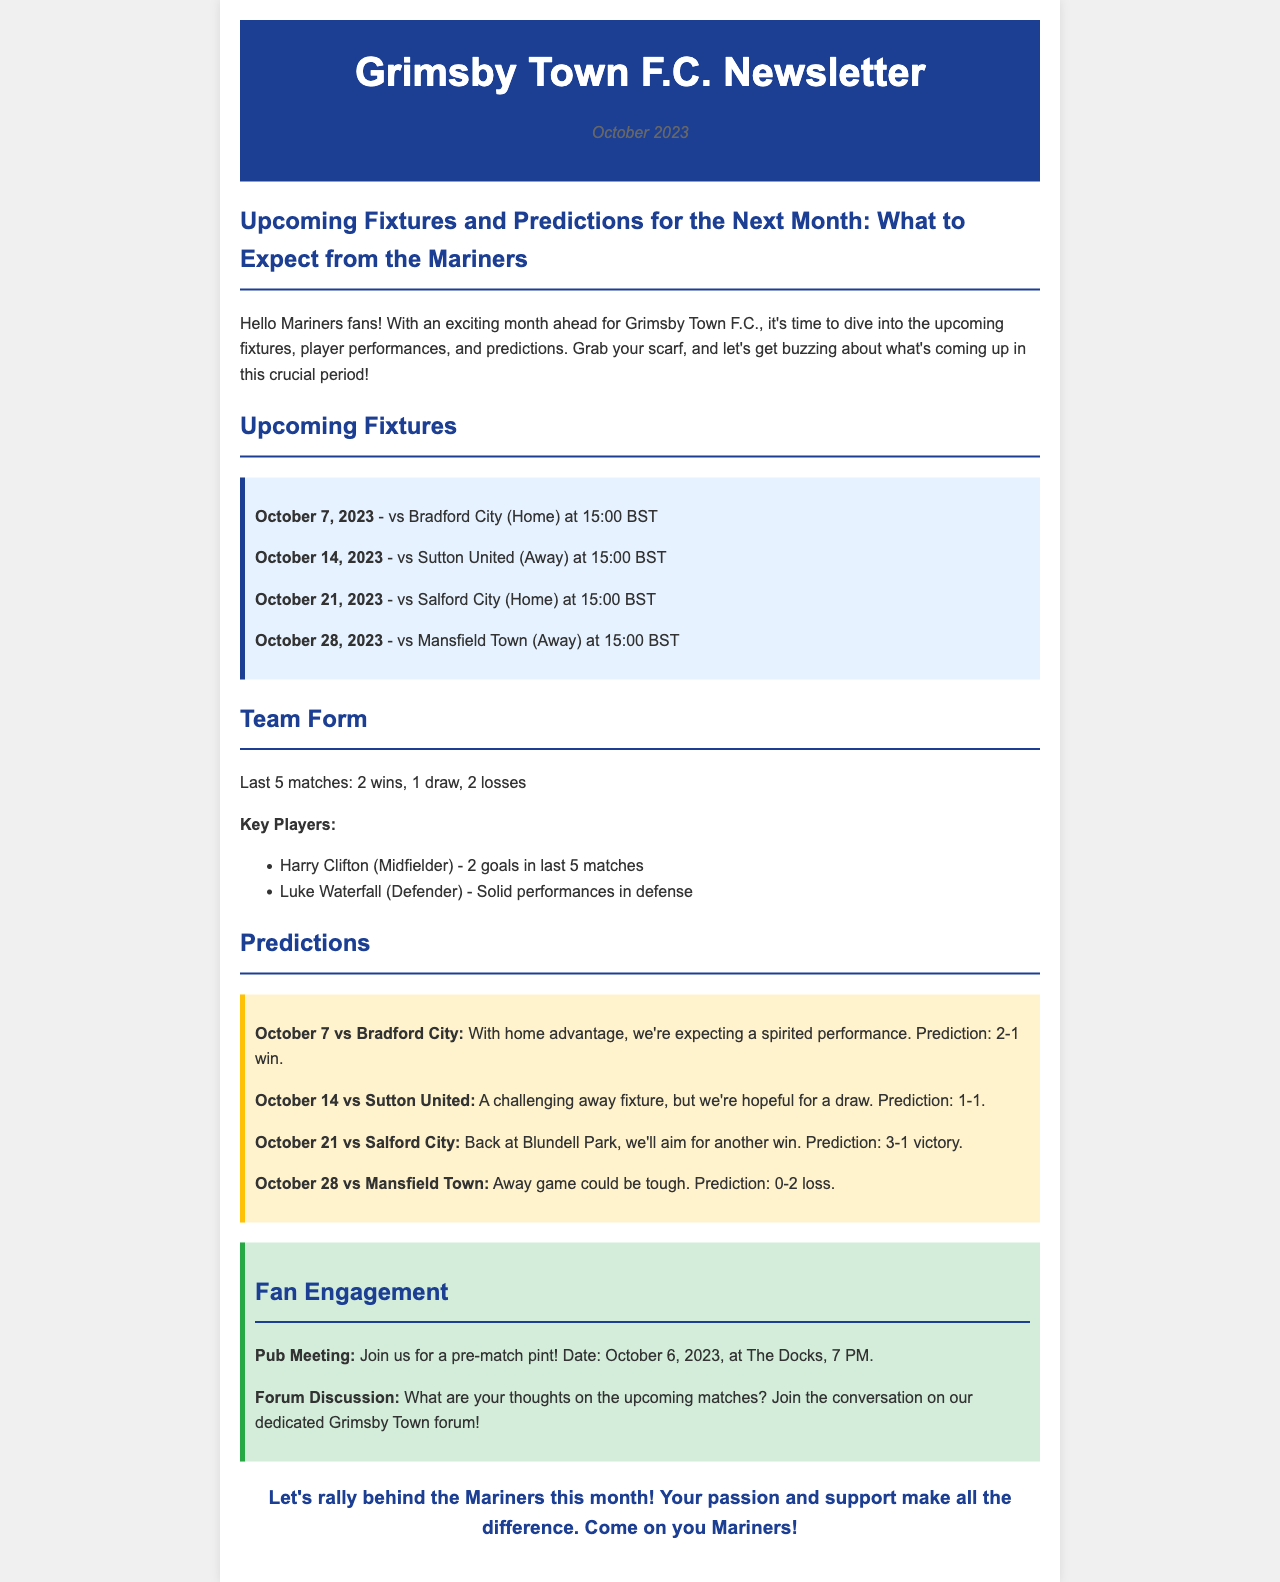What is the date of the home match against Bradford City? The date of the home match against Bradford City is mentioned in the fixtures section of the document.
Answer: October 7, 2023 How many wins did Grimsby Town have in their last 5 matches? The document states the team's last 5 matches include 2 wins.
Answer: 2 Which player scored 2 goals in the last 5 matches? The document lists Harry Clifton as the player who scored 2 goals in the last 5 matches.
Answer: Harry Clifton What is the predicted score for the away match against Mansfield Town? The document provides a prediction for the away match against Mansfield Town stating the expected score.
Answer: 0-2 loss What time does the match against Sutton United start? The match time for the fixture against Sutton United is provided in the upcoming fixtures section.
Answer: 15:00 BST What is the date and location for the pub meeting? The document mentions the date and location of a pub meeting for fans to join.
Answer: October 6, 2023, at The Docks How many goals are predicted for the match against Salford City? The predicted score for the match against Salford City indicates the total number of goals expected.
Answer: 3 What is the overall theme of the newsletter? The theme revolves around the upcoming fixtures and predictions for the next month regarding Grimsby Town F.C.
Answer: Upcoming Fixtures and Predictions 